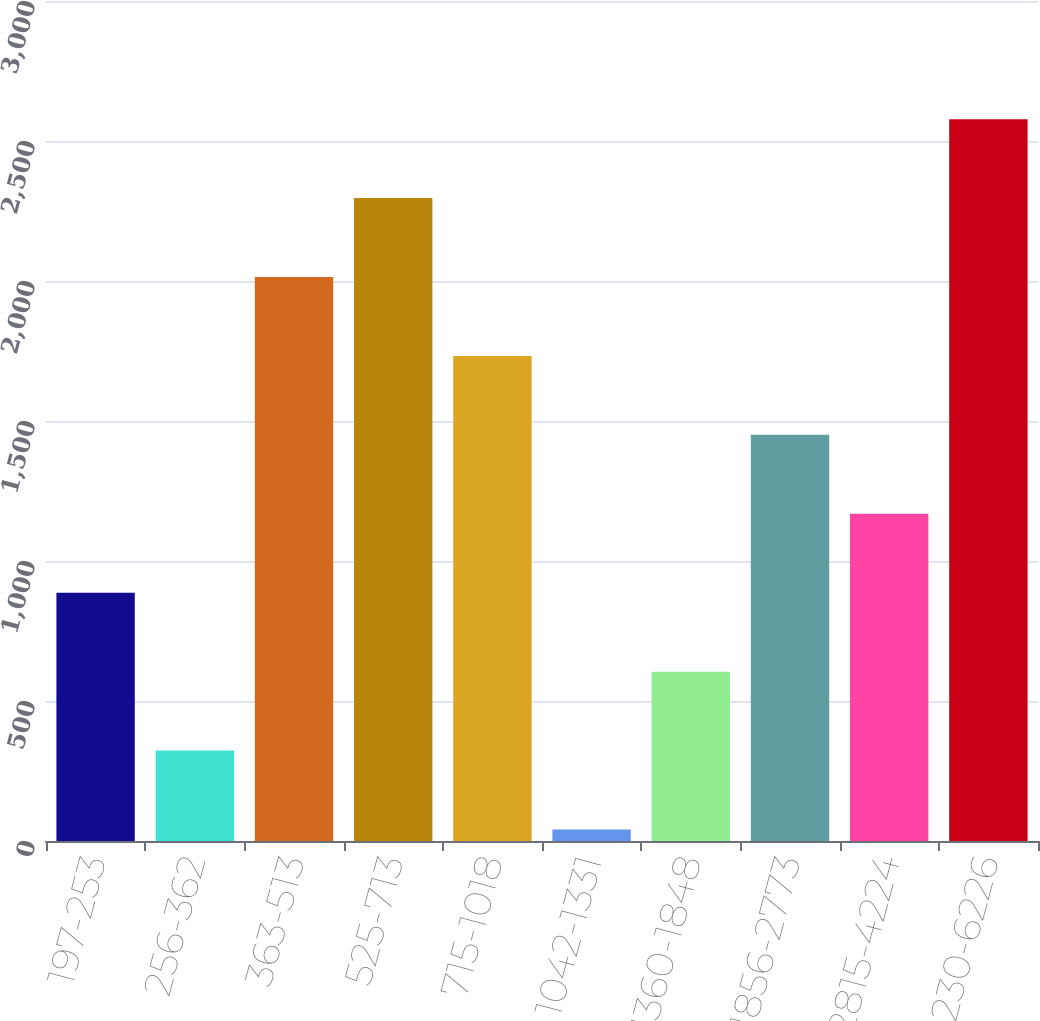Convert chart. <chart><loc_0><loc_0><loc_500><loc_500><bar_chart><fcel>197-253<fcel>256-362<fcel>363-513<fcel>525-713<fcel>715-1018<fcel>1042-1331<fcel>1360-1848<fcel>1856-2773<fcel>2815-4224<fcel>4230-6226<nl><fcel>886.7<fcel>322.9<fcel>2014.3<fcel>2296.2<fcel>1732.4<fcel>41<fcel>604.8<fcel>1450.5<fcel>1168.6<fcel>2578.1<nl></chart> 